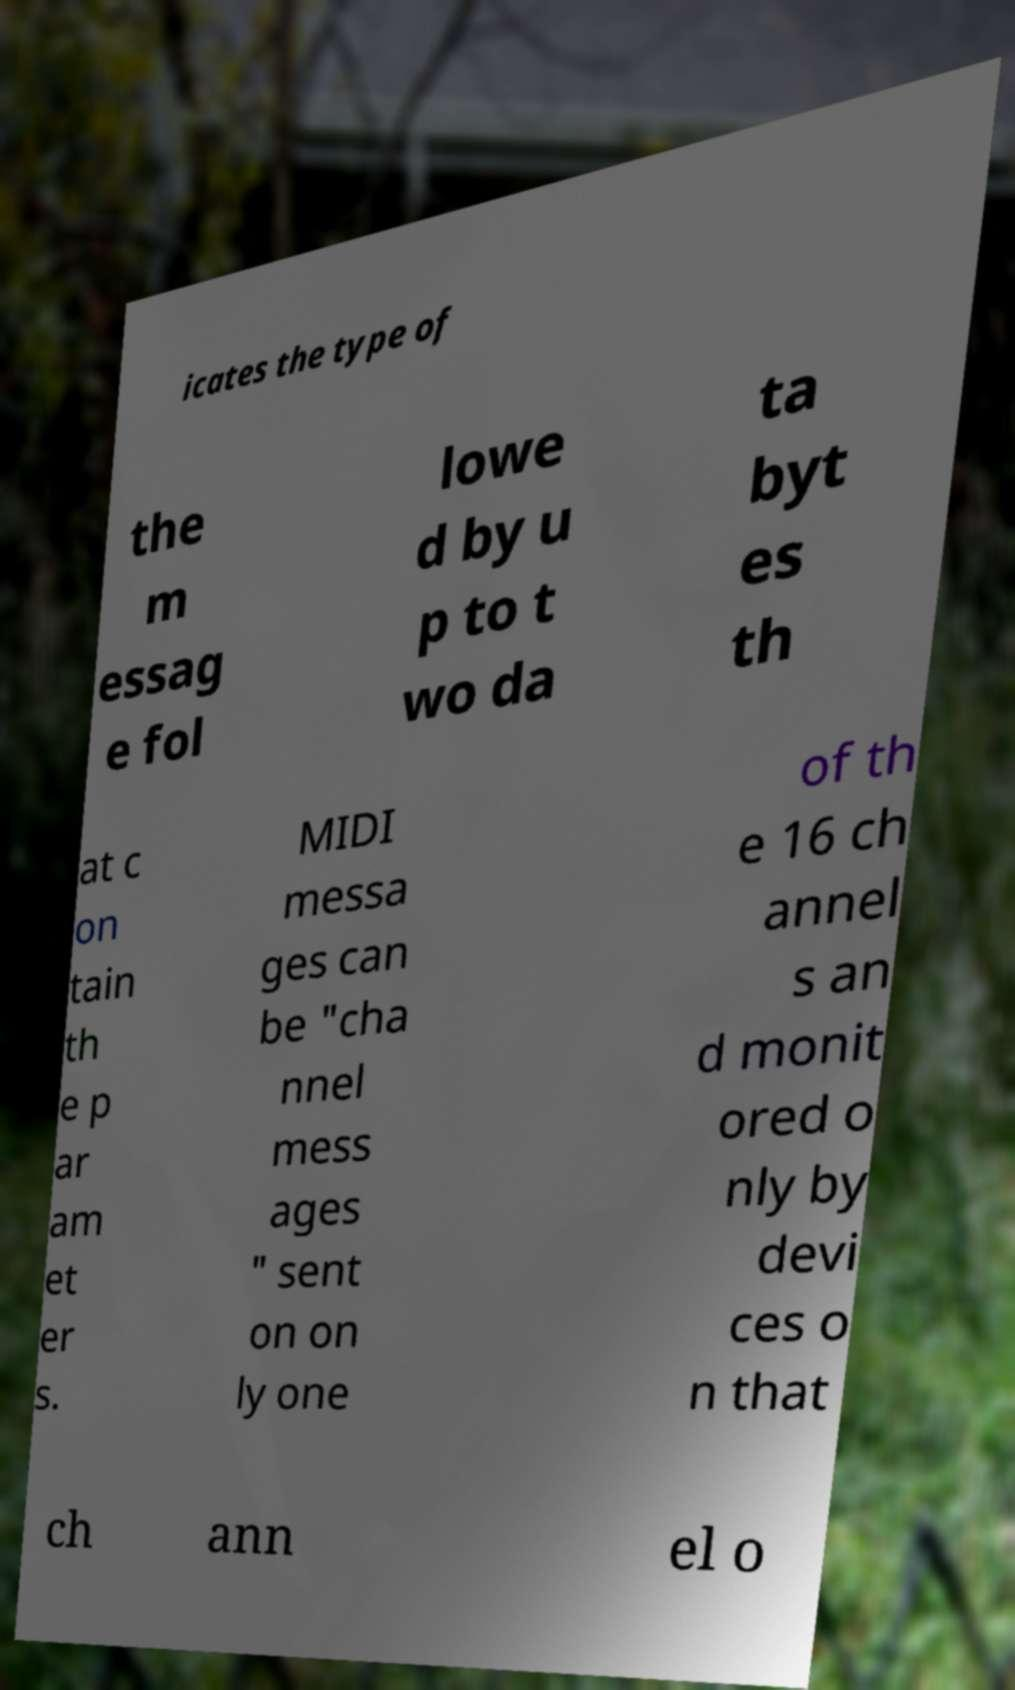There's text embedded in this image that I need extracted. Can you transcribe it verbatim? icates the type of the m essag e fol lowe d by u p to t wo da ta byt es th at c on tain th e p ar am et er s. MIDI messa ges can be "cha nnel mess ages " sent on on ly one of th e 16 ch annel s an d monit ored o nly by devi ces o n that ch ann el o 